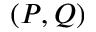Convert formula to latex. <formula><loc_0><loc_0><loc_500><loc_500>( P , Q )</formula> 